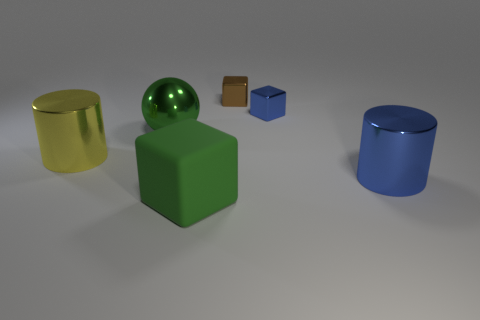Add 2 purple metallic things. How many objects exist? 8 Subtract all cylinders. How many objects are left? 4 Subtract all brown cubes. Subtract all green things. How many objects are left? 3 Add 1 small brown shiny objects. How many small brown shiny objects are left? 2 Add 1 small brown things. How many small brown things exist? 2 Subtract 1 yellow cylinders. How many objects are left? 5 